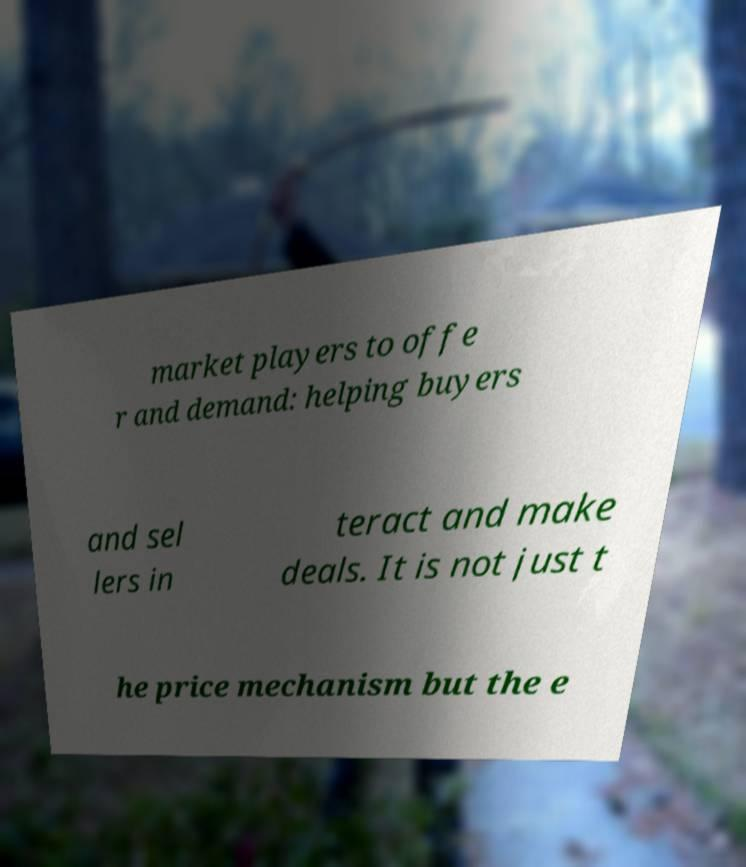For documentation purposes, I need the text within this image transcribed. Could you provide that? market players to offe r and demand: helping buyers and sel lers in teract and make deals. It is not just t he price mechanism but the e 